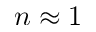Convert formula to latex. <formula><loc_0><loc_0><loc_500><loc_500>n \approx 1</formula> 